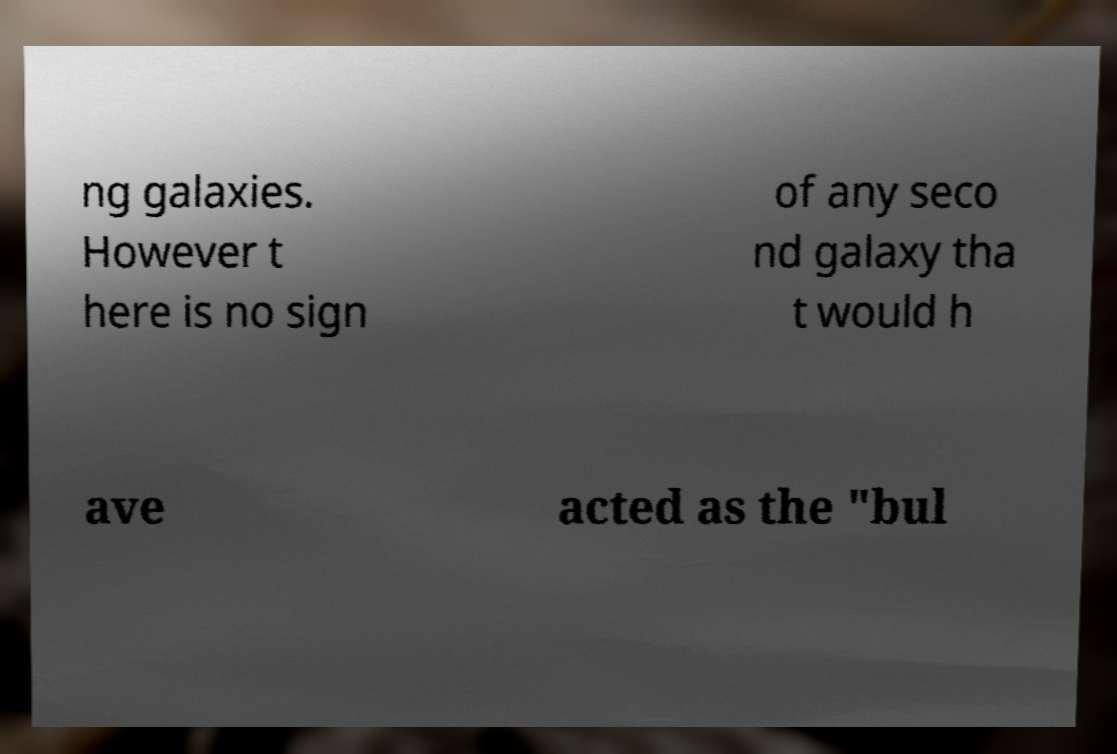For documentation purposes, I need the text within this image transcribed. Could you provide that? ng galaxies. However t here is no sign of any seco nd galaxy tha t would h ave acted as the "bul 